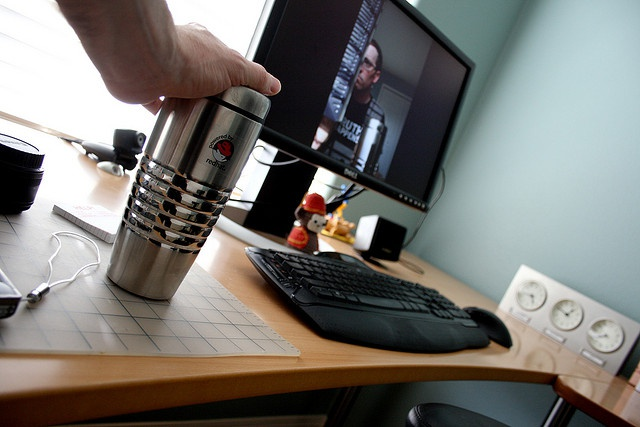Describe the objects in this image and their specific colors. I can see tv in white, black, gray, and darkblue tones, cup in white, black, and gray tones, keyboard in white, black, gray, purple, and darkgray tones, people in white, maroon, and gray tones, and people in white, black, gray, and darkblue tones in this image. 